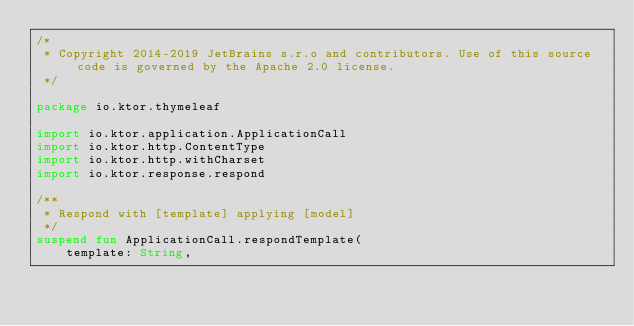<code> <loc_0><loc_0><loc_500><loc_500><_Kotlin_>/*
 * Copyright 2014-2019 JetBrains s.r.o and contributors. Use of this source code is governed by the Apache 2.0 license.
 */

package io.ktor.thymeleaf

import io.ktor.application.ApplicationCall
import io.ktor.http.ContentType
import io.ktor.http.withCharset
import io.ktor.response.respond

/**
 * Respond with [template] applying [model]
 */
suspend fun ApplicationCall.respondTemplate(
    template: String,</code> 